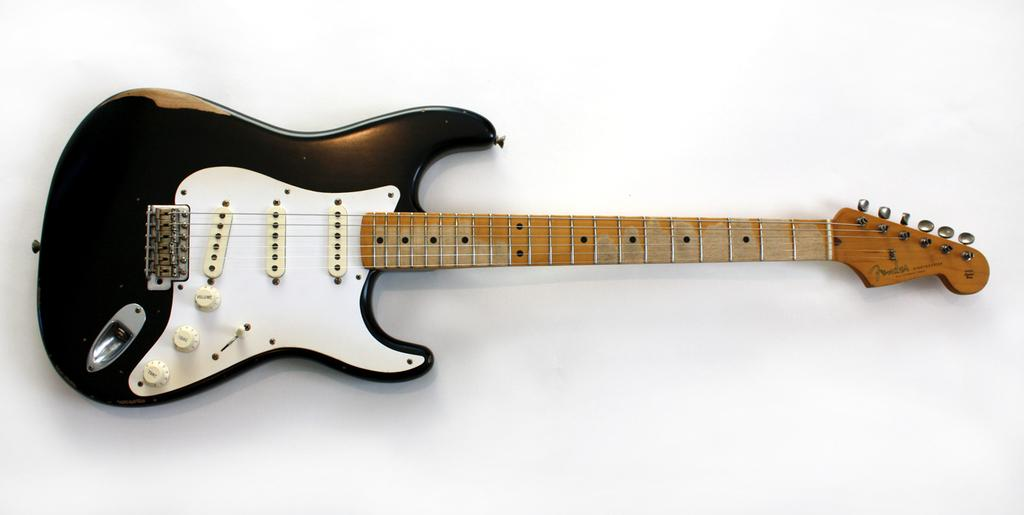What musical instrument is present in the image? There is a guitar in the image. Can you describe the guitar in the image? The image only shows a guitar, without any additional details. What type of music might be associated with the guitar? The guitar is a versatile instrument and can be used in various music genres. How many horses are visible in the image? There are no horses present in the image; it only features a guitar. What type of bait is used for the guitar in the image? There is no bait associated with the guitar in the image, as it is a musical instrument and not a fishing tool. 